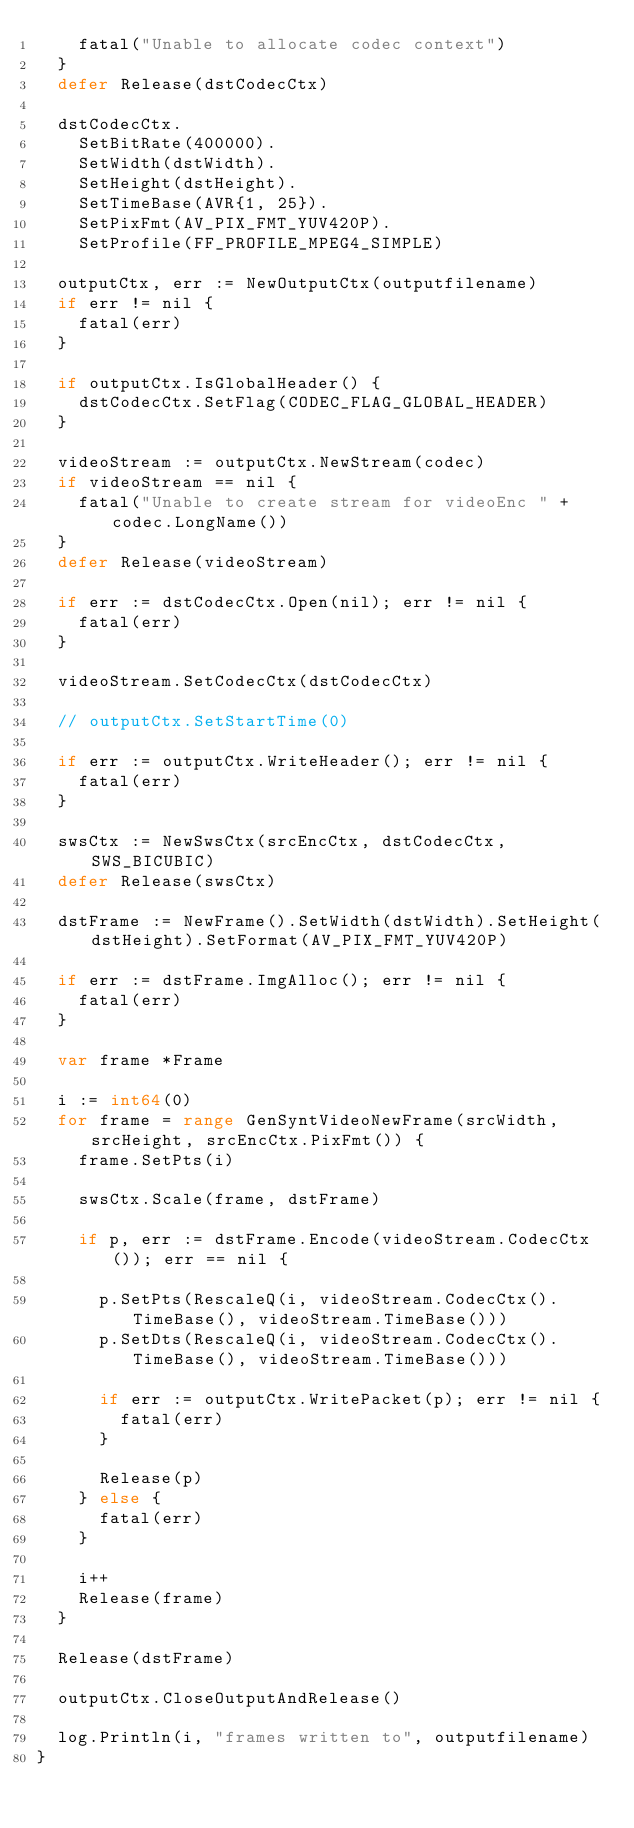<code> <loc_0><loc_0><loc_500><loc_500><_Go_>		fatal("Unable to allocate codec context")
	}
	defer Release(dstCodecCtx)

	dstCodecCtx.
		SetBitRate(400000).
		SetWidth(dstWidth).
		SetHeight(dstHeight).
		SetTimeBase(AVR{1, 25}).
		SetPixFmt(AV_PIX_FMT_YUV420P).
		SetProfile(FF_PROFILE_MPEG4_SIMPLE)

	outputCtx, err := NewOutputCtx(outputfilename)
	if err != nil {
		fatal(err)
	}

	if outputCtx.IsGlobalHeader() {
		dstCodecCtx.SetFlag(CODEC_FLAG_GLOBAL_HEADER)
	}

	videoStream := outputCtx.NewStream(codec)
	if videoStream == nil {
		fatal("Unable to create stream for videoEnc " + codec.LongName())
	}
	defer Release(videoStream)

	if err := dstCodecCtx.Open(nil); err != nil {
		fatal(err)
	}

	videoStream.SetCodecCtx(dstCodecCtx)

	// outputCtx.SetStartTime(0)

	if err := outputCtx.WriteHeader(); err != nil {
		fatal(err)
	}

	swsCtx := NewSwsCtx(srcEncCtx, dstCodecCtx, SWS_BICUBIC)
	defer Release(swsCtx)

	dstFrame := NewFrame().SetWidth(dstWidth).SetHeight(dstHeight).SetFormat(AV_PIX_FMT_YUV420P)

	if err := dstFrame.ImgAlloc(); err != nil {
		fatal(err)
	}

	var frame *Frame

	i := int64(0)
	for frame = range GenSyntVideoNewFrame(srcWidth, srcHeight, srcEncCtx.PixFmt()) {
		frame.SetPts(i)

		swsCtx.Scale(frame, dstFrame)

		if p, err := dstFrame.Encode(videoStream.CodecCtx()); err == nil {

			p.SetPts(RescaleQ(i, videoStream.CodecCtx().TimeBase(), videoStream.TimeBase()))
			p.SetDts(RescaleQ(i, videoStream.CodecCtx().TimeBase(), videoStream.TimeBase()))

			if err := outputCtx.WritePacket(p); err != nil {
				fatal(err)
			}

			Release(p)
		} else {
			fatal(err)
		}

		i++
		Release(frame)
	}

	Release(dstFrame)

	outputCtx.CloseOutputAndRelease()

	log.Println(i, "frames written to", outputfilename)
}
</code> 